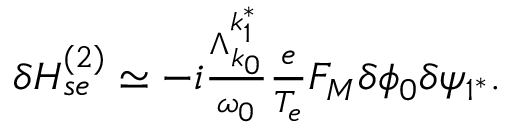<formula> <loc_0><loc_0><loc_500><loc_500>\begin{array} { r } { \delta H _ { s e } ^ { ( 2 ) } \simeq - i \frac { \Lambda _ { k _ { 0 } } ^ { k _ { 1 } ^ { * } } } { \omega _ { 0 } } \frac { e } { T _ { e } } F _ { M } \delta \phi _ { 0 } \delta \psi _ { 1 ^ { * } } . } \end{array}</formula> 